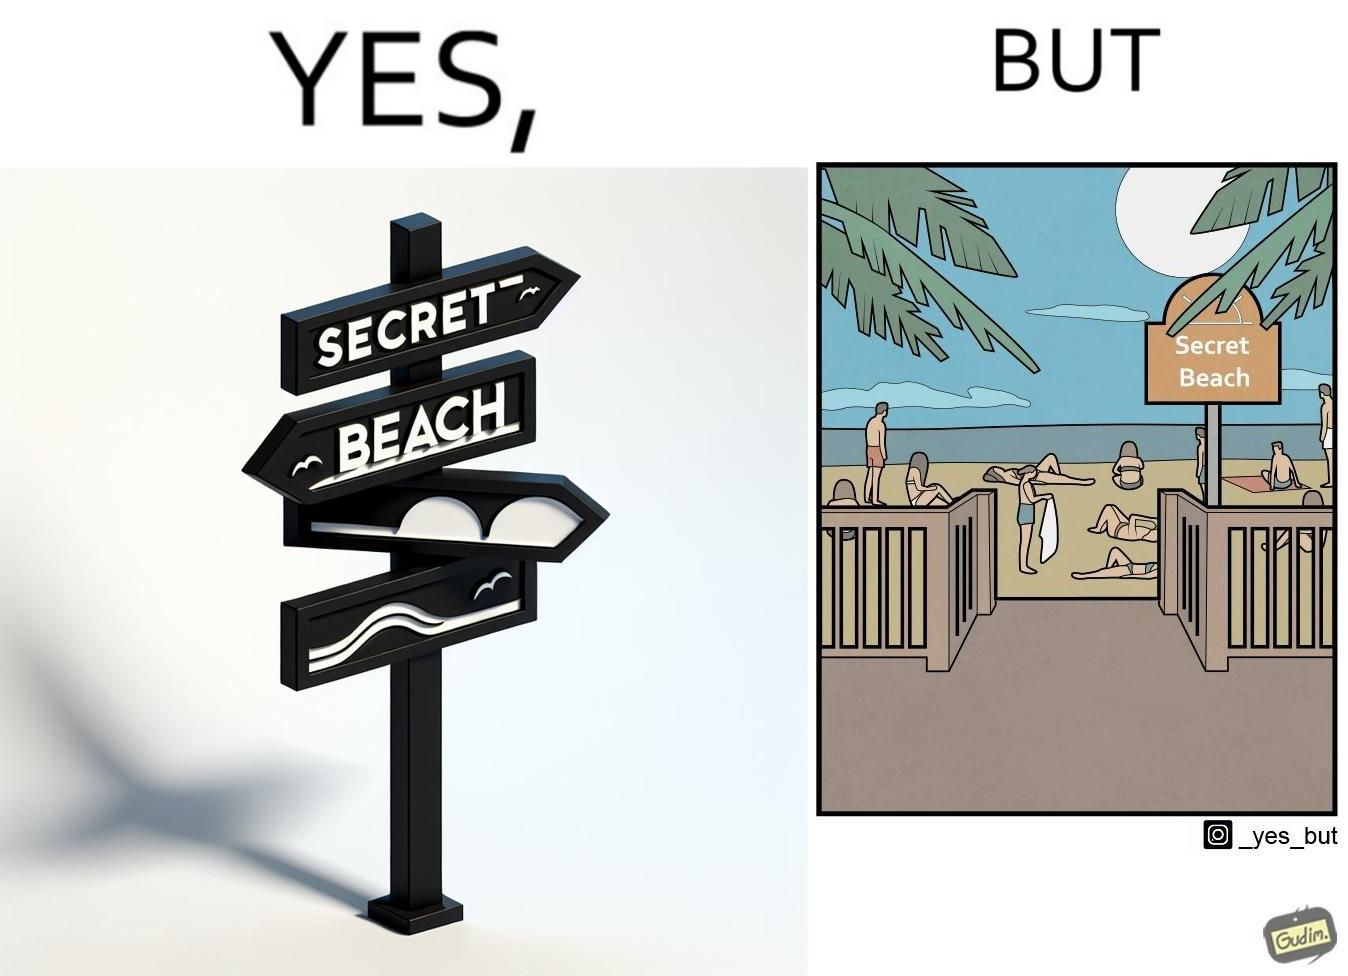Describe the satirical element in this image. The image is ironical, as people can be seen in the beach, and is clearly not a secret, while the board at the entrance has "Secret Beach" written on it. 